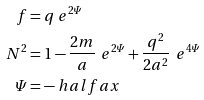Convert formula to latex. <formula><loc_0><loc_0><loc_500><loc_500>f & = q \ e ^ { 2 \varPsi } \\ N ^ { 2 } & = 1 - \frac { 2 m } { a } \, \ e ^ { 2 \varPsi } + \frac { q ^ { 2 } } { 2 a ^ { 2 } } \, \ e ^ { 4 \varPsi } \\ \varPsi & = - \ h a l f a x</formula> 